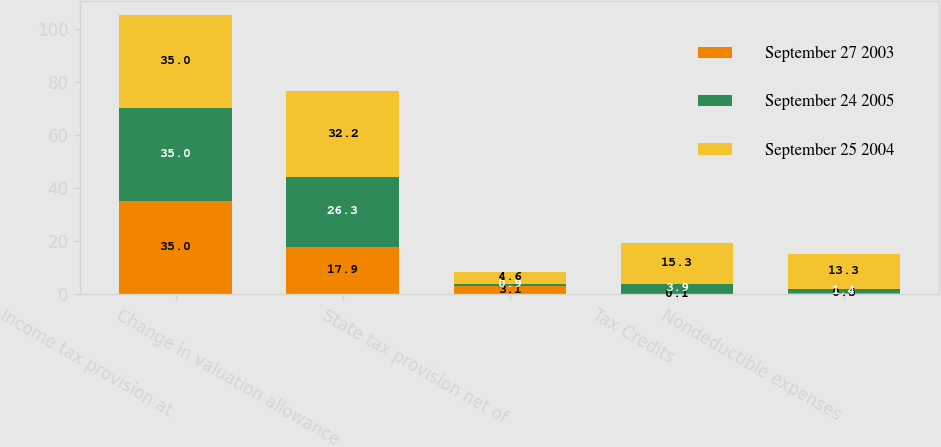Convert chart to OTSL. <chart><loc_0><loc_0><loc_500><loc_500><stacked_bar_chart><ecel><fcel>Income tax provision at<fcel>Change in valuation allowance<fcel>State tax provision net of<fcel>Tax Credits<fcel>Nondeductible expenses<nl><fcel>September 27 2003<fcel>35<fcel>17.9<fcel>3.1<fcel>0.1<fcel>0.5<nl><fcel>September 24 2005<fcel>35<fcel>26.3<fcel>0.9<fcel>3.9<fcel>1.4<nl><fcel>September 25 2004<fcel>35<fcel>32.2<fcel>4.6<fcel>15.3<fcel>13.3<nl></chart> 